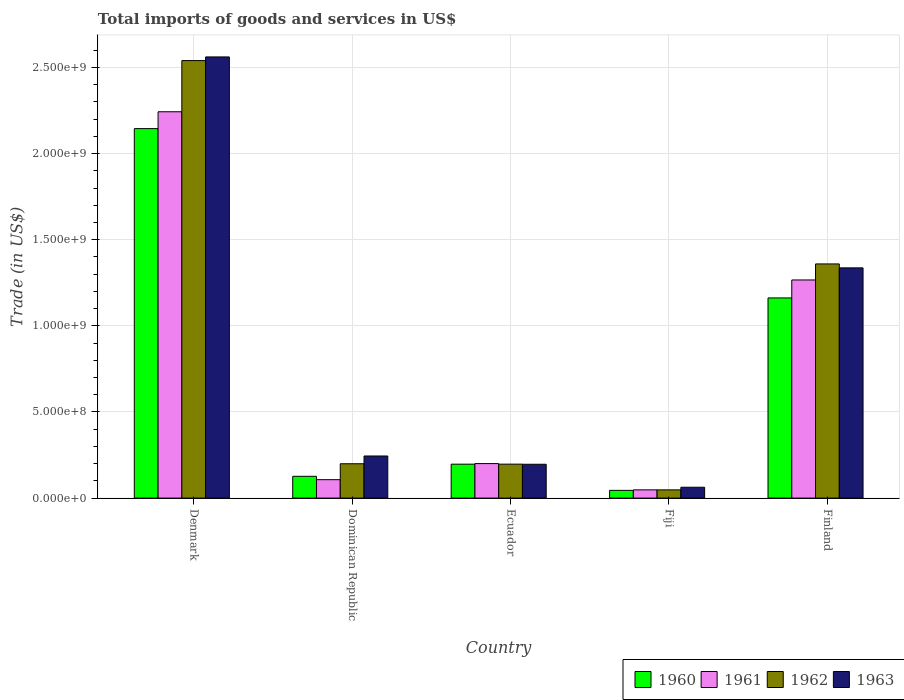How many different coloured bars are there?
Offer a very short reply. 4. Are the number of bars on each tick of the X-axis equal?
Offer a terse response. Yes. How many bars are there on the 4th tick from the left?
Your answer should be compact. 4. How many bars are there on the 3rd tick from the right?
Your response must be concise. 4. In how many cases, is the number of bars for a given country not equal to the number of legend labels?
Your response must be concise. 0. What is the total imports of goods and services in 1961 in Fiji?
Provide a succinct answer. 4.77e+07. Across all countries, what is the maximum total imports of goods and services in 1963?
Make the answer very short. 2.56e+09. Across all countries, what is the minimum total imports of goods and services in 1962?
Keep it short and to the point. 4.77e+07. In which country was the total imports of goods and services in 1962 maximum?
Your answer should be very brief. Denmark. In which country was the total imports of goods and services in 1960 minimum?
Your answer should be compact. Fiji. What is the total total imports of goods and services in 1963 in the graph?
Your answer should be very brief. 4.40e+09. What is the difference between the total imports of goods and services in 1963 in Denmark and that in Finland?
Offer a terse response. 1.22e+09. What is the difference between the total imports of goods and services in 1962 in Ecuador and the total imports of goods and services in 1963 in Fiji?
Offer a terse response. 1.34e+08. What is the average total imports of goods and services in 1961 per country?
Your answer should be very brief. 7.73e+08. What is the difference between the total imports of goods and services of/in 1960 and total imports of goods and services of/in 1961 in Fiji?
Provide a short and direct response. -2.90e+06. What is the ratio of the total imports of goods and services in 1960 in Dominican Republic to that in Finland?
Your response must be concise. 0.11. Is the difference between the total imports of goods and services in 1960 in Denmark and Dominican Republic greater than the difference between the total imports of goods and services in 1961 in Denmark and Dominican Republic?
Give a very brief answer. No. What is the difference between the highest and the second highest total imports of goods and services in 1962?
Offer a very short reply. -1.16e+09. What is the difference between the highest and the lowest total imports of goods and services in 1961?
Provide a succinct answer. 2.19e+09. Is the sum of the total imports of goods and services in 1962 in Fiji and Finland greater than the maximum total imports of goods and services in 1961 across all countries?
Give a very brief answer. No. Is it the case that in every country, the sum of the total imports of goods and services in 1960 and total imports of goods and services in 1962 is greater than the sum of total imports of goods and services in 1961 and total imports of goods and services in 1963?
Give a very brief answer. No. What does the 3rd bar from the right in Fiji represents?
Offer a terse response. 1961. Are the values on the major ticks of Y-axis written in scientific E-notation?
Offer a very short reply. Yes. Does the graph contain any zero values?
Provide a short and direct response. No. How many legend labels are there?
Ensure brevity in your answer.  4. What is the title of the graph?
Provide a short and direct response. Total imports of goods and services in US$. Does "1970" appear as one of the legend labels in the graph?
Your answer should be compact. No. What is the label or title of the Y-axis?
Give a very brief answer. Trade (in US$). What is the Trade (in US$) in 1960 in Denmark?
Give a very brief answer. 2.14e+09. What is the Trade (in US$) of 1961 in Denmark?
Your answer should be compact. 2.24e+09. What is the Trade (in US$) in 1962 in Denmark?
Your response must be concise. 2.54e+09. What is the Trade (in US$) in 1963 in Denmark?
Make the answer very short. 2.56e+09. What is the Trade (in US$) in 1960 in Dominican Republic?
Keep it short and to the point. 1.26e+08. What is the Trade (in US$) of 1961 in Dominican Republic?
Make the answer very short. 1.07e+08. What is the Trade (in US$) in 1962 in Dominican Republic?
Offer a very short reply. 1.99e+08. What is the Trade (in US$) of 1963 in Dominican Republic?
Give a very brief answer. 2.44e+08. What is the Trade (in US$) in 1960 in Ecuador?
Offer a terse response. 1.97e+08. What is the Trade (in US$) in 1961 in Ecuador?
Ensure brevity in your answer.  2.00e+08. What is the Trade (in US$) of 1962 in Ecuador?
Ensure brevity in your answer.  1.97e+08. What is the Trade (in US$) in 1963 in Ecuador?
Give a very brief answer. 1.96e+08. What is the Trade (in US$) in 1960 in Fiji?
Make the answer very short. 4.48e+07. What is the Trade (in US$) in 1961 in Fiji?
Give a very brief answer. 4.77e+07. What is the Trade (in US$) of 1962 in Fiji?
Your response must be concise. 4.77e+07. What is the Trade (in US$) of 1963 in Fiji?
Provide a succinct answer. 6.30e+07. What is the Trade (in US$) in 1960 in Finland?
Keep it short and to the point. 1.16e+09. What is the Trade (in US$) of 1961 in Finland?
Keep it short and to the point. 1.27e+09. What is the Trade (in US$) of 1962 in Finland?
Your response must be concise. 1.36e+09. What is the Trade (in US$) of 1963 in Finland?
Make the answer very short. 1.34e+09. Across all countries, what is the maximum Trade (in US$) in 1960?
Provide a succinct answer. 2.14e+09. Across all countries, what is the maximum Trade (in US$) of 1961?
Offer a terse response. 2.24e+09. Across all countries, what is the maximum Trade (in US$) of 1962?
Provide a short and direct response. 2.54e+09. Across all countries, what is the maximum Trade (in US$) in 1963?
Your response must be concise. 2.56e+09. Across all countries, what is the minimum Trade (in US$) of 1960?
Give a very brief answer. 4.48e+07. Across all countries, what is the minimum Trade (in US$) of 1961?
Make the answer very short. 4.77e+07. Across all countries, what is the minimum Trade (in US$) in 1962?
Your answer should be very brief. 4.77e+07. Across all countries, what is the minimum Trade (in US$) in 1963?
Your answer should be compact. 6.30e+07. What is the total Trade (in US$) in 1960 in the graph?
Offer a very short reply. 3.67e+09. What is the total Trade (in US$) in 1961 in the graph?
Make the answer very short. 3.86e+09. What is the total Trade (in US$) of 1962 in the graph?
Provide a short and direct response. 4.34e+09. What is the total Trade (in US$) in 1963 in the graph?
Offer a very short reply. 4.40e+09. What is the difference between the Trade (in US$) of 1960 in Denmark and that in Dominican Republic?
Your answer should be compact. 2.02e+09. What is the difference between the Trade (in US$) in 1961 in Denmark and that in Dominican Republic?
Provide a succinct answer. 2.14e+09. What is the difference between the Trade (in US$) in 1962 in Denmark and that in Dominican Republic?
Keep it short and to the point. 2.34e+09. What is the difference between the Trade (in US$) in 1963 in Denmark and that in Dominican Republic?
Offer a terse response. 2.32e+09. What is the difference between the Trade (in US$) of 1960 in Denmark and that in Ecuador?
Provide a succinct answer. 1.95e+09. What is the difference between the Trade (in US$) in 1961 in Denmark and that in Ecuador?
Offer a very short reply. 2.04e+09. What is the difference between the Trade (in US$) of 1962 in Denmark and that in Ecuador?
Your answer should be very brief. 2.34e+09. What is the difference between the Trade (in US$) of 1963 in Denmark and that in Ecuador?
Your answer should be very brief. 2.36e+09. What is the difference between the Trade (in US$) in 1960 in Denmark and that in Fiji?
Offer a very short reply. 2.10e+09. What is the difference between the Trade (in US$) in 1961 in Denmark and that in Fiji?
Ensure brevity in your answer.  2.19e+09. What is the difference between the Trade (in US$) of 1962 in Denmark and that in Fiji?
Provide a short and direct response. 2.49e+09. What is the difference between the Trade (in US$) in 1963 in Denmark and that in Fiji?
Offer a terse response. 2.50e+09. What is the difference between the Trade (in US$) in 1960 in Denmark and that in Finland?
Provide a succinct answer. 9.83e+08. What is the difference between the Trade (in US$) of 1961 in Denmark and that in Finland?
Give a very brief answer. 9.76e+08. What is the difference between the Trade (in US$) of 1962 in Denmark and that in Finland?
Your response must be concise. 1.18e+09. What is the difference between the Trade (in US$) in 1963 in Denmark and that in Finland?
Give a very brief answer. 1.22e+09. What is the difference between the Trade (in US$) in 1960 in Dominican Republic and that in Ecuador?
Ensure brevity in your answer.  -7.04e+07. What is the difference between the Trade (in US$) of 1961 in Dominican Republic and that in Ecuador?
Keep it short and to the point. -9.34e+07. What is the difference between the Trade (in US$) in 1962 in Dominican Republic and that in Ecuador?
Provide a succinct answer. 2.27e+06. What is the difference between the Trade (in US$) of 1963 in Dominican Republic and that in Ecuador?
Make the answer very short. 4.80e+07. What is the difference between the Trade (in US$) of 1960 in Dominican Republic and that in Fiji?
Offer a very short reply. 8.17e+07. What is the difference between the Trade (in US$) in 1961 in Dominican Republic and that in Fiji?
Provide a succinct answer. 5.92e+07. What is the difference between the Trade (in US$) of 1962 in Dominican Republic and that in Fiji?
Your answer should be compact. 1.52e+08. What is the difference between the Trade (in US$) in 1963 in Dominican Republic and that in Fiji?
Make the answer very short. 1.81e+08. What is the difference between the Trade (in US$) of 1960 in Dominican Republic and that in Finland?
Offer a terse response. -1.04e+09. What is the difference between the Trade (in US$) in 1961 in Dominican Republic and that in Finland?
Provide a short and direct response. -1.16e+09. What is the difference between the Trade (in US$) in 1962 in Dominican Republic and that in Finland?
Ensure brevity in your answer.  -1.16e+09. What is the difference between the Trade (in US$) in 1963 in Dominican Republic and that in Finland?
Offer a terse response. -1.09e+09. What is the difference between the Trade (in US$) in 1960 in Ecuador and that in Fiji?
Provide a short and direct response. 1.52e+08. What is the difference between the Trade (in US$) of 1961 in Ecuador and that in Fiji?
Your answer should be very brief. 1.53e+08. What is the difference between the Trade (in US$) of 1962 in Ecuador and that in Fiji?
Provide a succinct answer. 1.49e+08. What is the difference between the Trade (in US$) of 1963 in Ecuador and that in Fiji?
Provide a short and direct response. 1.33e+08. What is the difference between the Trade (in US$) in 1960 in Ecuador and that in Finland?
Your answer should be compact. -9.65e+08. What is the difference between the Trade (in US$) in 1961 in Ecuador and that in Finland?
Your answer should be compact. -1.07e+09. What is the difference between the Trade (in US$) in 1962 in Ecuador and that in Finland?
Your response must be concise. -1.16e+09. What is the difference between the Trade (in US$) of 1963 in Ecuador and that in Finland?
Make the answer very short. -1.14e+09. What is the difference between the Trade (in US$) in 1960 in Fiji and that in Finland?
Ensure brevity in your answer.  -1.12e+09. What is the difference between the Trade (in US$) of 1961 in Fiji and that in Finland?
Your answer should be very brief. -1.22e+09. What is the difference between the Trade (in US$) of 1962 in Fiji and that in Finland?
Make the answer very short. -1.31e+09. What is the difference between the Trade (in US$) of 1963 in Fiji and that in Finland?
Provide a short and direct response. -1.27e+09. What is the difference between the Trade (in US$) in 1960 in Denmark and the Trade (in US$) in 1961 in Dominican Republic?
Your response must be concise. 2.04e+09. What is the difference between the Trade (in US$) in 1960 in Denmark and the Trade (in US$) in 1962 in Dominican Republic?
Your answer should be very brief. 1.95e+09. What is the difference between the Trade (in US$) of 1960 in Denmark and the Trade (in US$) of 1963 in Dominican Republic?
Your answer should be compact. 1.90e+09. What is the difference between the Trade (in US$) in 1961 in Denmark and the Trade (in US$) in 1962 in Dominican Republic?
Your response must be concise. 2.04e+09. What is the difference between the Trade (in US$) in 1961 in Denmark and the Trade (in US$) in 1963 in Dominican Republic?
Offer a very short reply. 2.00e+09. What is the difference between the Trade (in US$) in 1962 in Denmark and the Trade (in US$) in 1963 in Dominican Republic?
Your answer should be compact. 2.30e+09. What is the difference between the Trade (in US$) in 1960 in Denmark and the Trade (in US$) in 1961 in Ecuador?
Give a very brief answer. 1.94e+09. What is the difference between the Trade (in US$) in 1960 in Denmark and the Trade (in US$) in 1962 in Ecuador?
Offer a very short reply. 1.95e+09. What is the difference between the Trade (in US$) in 1960 in Denmark and the Trade (in US$) in 1963 in Ecuador?
Ensure brevity in your answer.  1.95e+09. What is the difference between the Trade (in US$) in 1961 in Denmark and the Trade (in US$) in 1962 in Ecuador?
Give a very brief answer. 2.05e+09. What is the difference between the Trade (in US$) of 1961 in Denmark and the Trade (in US$) of 1963 in Ecuador?
Your answer should be very brief. 2.05e+09. What is the difference between the Trade (in US$) of 1962 in Denmark and the Trade (in US$) of 1963 in Ecuador?
Offer a very short reply. 2.34e+09. What is the difference between the Trade (in US$) of 1960 in Denmark and the Trade (in US$) of 1961 in Fiji?
Provide a short and direct response. 2.10e+09. What is the difference between the Trade (in US$) in 1960 in Denmark and the Trade (in US$) in 1962 in Fiji?
Your response must be concise. 2.10e+09. What is the difference between the Trade (in US$) in 1960 in Denmark and the Trade (in US$) in 1963 in Fiji?
Keep it short and to the point. 2.08e+09. What is the difference between the Trade (in US$) in 1961 in Denmark and the Trade (in US$) in 1962 in Fiji?
Offer a very short reply. 2.19e+09. What is the difference between the Trade (in US$) in 1961 in Denmark and the Trade (in US$) in 1963 in Fiji?
Your response must be concise. 2.18e+09. What is the difference between the Trade (in US$) in 1962 in Denmark and the Trade (in US$) in 1963 in Fiji?
Provide a short and direct response. 2.48e+09. What is the difference between the Trade (in US$) of 1960 in Denmark and the Trade (in US$) of 1961 in Finland?
Your response must be concise. 8.79e+08. What is the difference between the Trade (in US$) of 1960 in Denmark and the Trade (in US$) of 1962 in Finland?
Offer a very short reply. 7.85e+08. What is the difference between the Trade (in US$) in 1960 in Denmark and the Trade (in US$) in 1963 in Finland?
Provide a succinct answer. 8.08e+08. What is the difference between the Trade (in US$) in 1961 in Denmark and the Trade (in US$) in 1962 in Finland?
Your answer should be very brief. 8.83e+08. What is the difference between the Trade (in US$) of 1961 in Denmark and the Trade (in US$) of 1963 in Finland?
Provide a short and direct response. 9.06e+08. What is the difference between the Trade (in US$) in 1962 in Denmark and the Trade (in US$) in 1963 in Finland?
Offer a very short reply. 1.20e+09. What is the difference between the Trade (in US$) of 1960 in Dominican Republic and the Trade (in US$) of 1961 in Ecuador?
Your answer should be very brief. -7.38e+07. What is the difference between the Trade (in US$) in 1960 in Dominican Republic and the Trade (in US$) in 1962 in Ecuador?
Give a very brief answer. -7.05e+07. What is the difference between the Trade (in US$) in 1960 in Dominican Republic and the Trade (in US$) in 1963 in Ecuador?
Make the answer very short. -6.99e+07. What is the difference between the Trade (in US$) of 1961 in Dominican Republic and the Trade (in US$) of 1962 in Ecuador?
Keep it short and to the point. -9.01e+07. What is the difference between the Trade (in US$) of 1961 in Dominican Republic and the Trade (in US$) of 1963 in Ecuador?
Keep it short and to the point. -8.95e+07. What is the difference between the Trade (in US$) in 1962 in Dominican Republic and the Trade (in US$) in 1963 in Ecuador?
Keep it short and to the point. 2.94e+06. What is the difference between the Trade (in US$) of 1960 in Dominican Republic and the Trade (in US$) of 1961 in Fiji?
Your answer should be very brief. 7.88e+07. What is the difference between the Trade (in US$) of 1960 in Dominican Republic and the Trade (in US$) of 1962 in Fiji?
Give a very brief answer. 7.88e+07. What is the difference between the Trade (in US$) in 1960 in Dominican Republic and the Trade (in US$) in 1963 in Fiji?
Make the answer very short. 6.35e+07. What is the difference between the Trade (in US$) of 1961 in Dominican Republic and the Trade (in US$) of 1962 in Fiji?
Ensure brevity in your answer.  5.92e+07. What is the difference between the Trade (in US$) of 1961 in Dominican Republic and the Trade (in US$) of 1963 in Fiji?
Your response must be concise. 4.39e+07. What is the difference between the Trade (in US$) of 1962 in Dominican Republic and the Trade (in US$) of 1963 in Fiji?
Provide a succinct answer. 1.36e+08. What is the difference between the Trade (in US$) of 1960 in Dominican Republic and the Trade (in US$) of 1961 in Finland?
Your response must be concise. -1.14e+09. What is the difference between the Trade (in US$) in 1960 in Dominican Republic and the Trade (in US$) in 1962 in Finland?
Provide a short and direct response. -1.23e+09. What is the difference between the Trade (in US$) in 1960 in Dominican Republic and the Trade (in US$) in 1963 in Finland?
Provide a short and direct response. -1.21e+09. What is the difference between the Trade (in US$) in 1961 in Dominican Republic and the Trade (in US$) in 1962 in Finland?
Offer a very short reply. -1.25e+09. What is the difference between the Trade (in US$) of 1961 in Dominican Republic and the Trade (in US$) of 1963 in Finland?
Keep it short and to the point. -1.23e+09. What is the difference between the Trade (in US$) of 1962 in Dominican Republic and the Trade (in US$) of 1963 in Finland?
Keep it short and to the point. -1.14e+09. What is the difference between the Trade (in US$) of 1960 in Ecuador and the Trade (in US$) of 1961 in Fiji?
Offer a terse response. 1.49e+08. What is the difference between the Trade (in US$) in 1960 in Ecuador and the Trade (in US$) in 1962 in Fiji?
Give a very brief answer. 1.49e+08. What is the difference between the Trade (in US$) of 1960 in Ecuador and the Trade (in US$) of 1963 in Fiji?
Your answer should be compact. 1.34e+08. What is the difference between the Trade (in US$) of 1961 in Ecuador and the Trade (in US$) of 1962 in Fiji?
Offer a very short reply. 1.53e+08. What is the difference between the Trade (in US$) of 1961 in Ecuador and the Trade (in US$) of 1963 in Fiji?
Your response must be concise. 1.37e+08. What is the difference between the Trade (in US$) in 1962 in Ecuador and the Trade (in US$) in 1963 in Fiji?
Ensure brevity in your answer.  1.34e+08. What is the difference between the Trade (in US$) of 1960 in Ecuador and the Trade (in US$) of 1961 in Finland?
Your answer should be compact. -1.07e+09. What is the difference between the Trade (in US$) of 1960 in Ecuador and the Trade (in US$) of 1962 in Finland?
Ensure brevity in your answer.  -1.16e+09. What is the difference between the Trade (in US$) of 1960 in Ecuador and the Trade (in US$) of 1963 in Finland?
Offer a terse response. -1.14e+09. What is the difference between the Trade (in US$) in 1961 in Ecuador and the Trade (in US$) in 1962 in Finland?
Offer a very short reply. -1.16e+09. What is the difference between the Trade (in US$) in 1961 in Ecuador and the Trade (in US$) in 1963 in Finland?
Make the answer very short. -1.14e+09. What is the difference between the Trade (in US$) of 1962 in Ecuador and the Trade (in US$) of 1963 in Finland?
Offer a terse response. -1.14e+09. What is the difference between the Trade (in US$) of 1960 in Fiji and the Trade (in US$) of 1961 in Finland?
Keep it short and to the point. -1.22e+09. What is the difference between the Trade (in US$) of 1960 in Fiji and the Trade (in US$) of 1962 in Finland?
Ensure brevity in your answer.  -1.31e+09. What is the difference between the Trade (in US$) in 1960 in Fiji and the Trade (in US$) in 1963 in Finland?
Give a very brief answer. -1.29e+09. What is the difference between the Trade (in US$) of 1961 in Fiji and the Trade (in US$) of 1962 in Finland?
Give a very brief answer. -1.31e+09. What is the difference between the Trade (in US$) of 1961 in Fiji and the Trade (in US$) of 1963 in Finland?
Your response must be concise. -1.29e+09. What is the difference between the Trade (in US$) in 1962 in Fiji and the Trade (in US$) in 1963 in Finland?
Keep it short and to the point. -1.29e+09. What is the average Trade (in US$) in 1960 per country?
Ensure brevity in your answer.  7.35e+08. What is the average Trade (in US$) in 1961 per country?
Your answer should be very brief. 7.73e+08. What is the average Trade (in US$) in 1962 per country?
Ensure brevity in your answer.  8.69e+08. What is the average Trade (in US$) of 1963 per country?
Keep it short and to the point. 8.80e+08. What is the difference between the Trade (in US$) of 1960 and Trade (in US$) of 1961 in Denmark?
Your answer should be very brief. -9.78e+07. What is the difference between the Trade (in US$) of 1960 and Trade (in US$) of 1962 in Denmark?
Your response must be concise. -3.95e+08. What is the difference between the Trade (in US$) of 1960 and Trade (in US$) of 1963 in Denmark?
Your answer should be compact. -4.16e+08. What is the difference between the Trade (in US$) of 1961 and Trade (in US$) of 1962 in Denmark?
Provide a succinct answer. -2.97e+08. What is the difference between the Trade (in US$) in 1961 and Trade (in US$) in 1963 in Denmark?
Your answer should be compact. -3.18e+08. What is the difference between the Trade (in US$) in 1962 and Trade (in US$) in 1963 in Denmark?
Keep it short and to the point. -2.12e+07. What is the difference between the Trade (in US$) of 1960 and Trade (in US$) of 1961 in Dominican Republic?
Provide a short and direct response. 1.96e+07. What is the difference between the Trade (in US$) in 1960 and Trade (in US$) in 1962 in Dominican Republic?
Give a very brief answer. -7.28e+07. What is the difference between the Trade (in US$) of 1960 and Trade (in US$) of 1963 in Dominican Republic?
Make the answer very short. -1.18e+08. What is the difference between the Trade (in US$) in 1961 and Trade (in US$) in 1962 in Dominican Republic?
Keep it short and to the point. -9.24e+07. What is the difference between the Trade (in US$) in 1961 and Trade (in US$) in 1963 in Dominican Republic?
Your answer should be very brief. -1.38e+08. What is the difference between the Trade (in US$) of 1962 and Trade (in US$) of 1963 in Dominican Republic?
Offer a very short reply. -4.51e+07. What is the difference between the Trade (in US$) of 1960 and Trade (in US$) of 1961 in Ecuador?
Make the answer very short. -3.37e+06. What is the difference between the Trade (in US$) of 1960 and Trade (in US$) of 1962 in Ecuador?
Your answer should be compact. -1.34e+05. What is the difference between the Trade (in US$) of 1960 and Trade (in US$) of 1963 in Ecuador?
Make the answer very short. 5.38e+05. What is the difference between the Trade (in US$) in 1961 and Trade (in US$) in 1962 in Ecuador?
Provide a short and direct response. 3.24e+06. What is the difference between the Trade (in US$) in 1961 and Trade (in US$) in 1963 in Ecuador?
Provide a short and direct response. 3.91e+06. What is the difference between the Trade (in US$) in 1962 and Trade (in US$) in 1963 in Ecuador?
Your answer should be very brief. 6.72e+05. What is the difference between the Trade (in US$) in 1960 and Trade (in US$) in 1961 in Fiji?
Provide a succinct answer. -2.90e+06. What is the difference between the Trade (in US$) of 1960 and Trade (in US$) of 1962 in Fiji?
Keep it short and to the point. -2.90e+06. What is the difference between the Trade (in US$) in 1960 and Trade (in US$) in 1963 in Fiji?
Offer a terse response. -1.81e+07. What is the difference between the Trade (in US$) in 1961 and Trade (in US$) in 1962 in Fiji?
Provide a short and direct response. 0. What is the difference between the Trade (in US$) of 1961 and Trade (in US$) of 1963 in Fiji?
Ensure brevity in your answer.  -1.52e+07. What is the difference between the Trade (in US$) of 1962 and Trade (in US$) of 1963 in Fiji?
Provide a short and direct response. -1.52e+07. What is the difference between the Trade (in US$) of 1960 and Trade (in US$) of 1961 in Finland?
Provide a succinct answer. -1.04e+08. What is the difference between the Trade (in US$) of 1960 and Trade (in US$) of 1962 in Finland?
Ensure brevity in your answer.  -1.97e+08. What is the difference between the Trade (in US$) of 1960 and Trade (in US$) of 1963 in Finland?
Your answer should be very brief. -1.75e+08. What is the difference between the Trade (in US$) in 1961 and Trade (in US$) in 1962 in Finland?
Ensure brevity in your answer.  -9.31e+07. What is the difference between the Trade (in US$) in 1961 and Trade (in US$) in 1963 in Finland?
Ensure brevity in your answer.  -7.02e+07. What is the difference between the Trade (in US$) of 1962 and Trade (in US$) of 1963 in Finland?
Offer a very short reply. 2.29e+07. What is the ratio of the Trade (in US$) of 1960 in Denmark to that in Dominican Republic?
Your answer should be very brief. 16.95. What is the ratio of the Trade (in US$) of 1961 in Denmark to that in Dominican Republic?
Offer a terse response. 20.98. What is the ratio of the Trade (in US$) of 1962 in Denmark to that in Dominican Republic?
Your answer should be compact. 12.74. What is the ratio of the Trade (in US$) of 1963 in Denmark to that in Dominican Republic?
Provide a short and direct response. 10.48. What is the ratio of the Trade (in US$) of 1960 in Denmark to that in Ecuador?
Keep it short and to the point. 10.89. What is the ratio of the Trade (in US$) in 1961 in Denmark to that in Ecuador?
Offer a terse response. 11.2. What is the ratio of the Trade (in US$) of 1962 in Denmark to that in Ecuador?
Provide a short and direct response. 12.89. What is the ratio of the Trade (in US$) of 1963 in Denmark to that in Ecuador?
Your answer should be compact. 13.04. What is the ratio of the Trade (in US$) of 1960 in Denmark to that in Fiji?
Your answer should be very brief. 47.84. What is the ratio of the Trade (in US$) of 1961 in Denmark to that in Fiji?
Your answer should be compact. 46.98. What is the ratio of the Trade (in US$) in 1962 in Denmark to that in Fiji?
Offer a very short reply. 53.21. What is the ratio of the Trade (in US$) of 1963 in Denmark to that in Fiji?
Your response must be concise. 40.67. What is the ratio of the Trade (in US$) in 1960 in Denmark to that in Finland?
Your response must be concise. 1.85. What is the ratio of the Trade (in US$) of 1961 in Denmark to that in Finland?
Give a very brief answer. 1.77. What is the ratio of the Trade (in US$) in 1962 in Denmark to that in Finland?
Provide a succinct answer. 1.87. What is the ratio of the Trade (in US$) in 1963 in Denmark to that in Finland?
Keep it short and to the point. 1.92. What is the ratio of the Trade (in US$) of 1960 in Dominican Republic to that in Ecuador?
Keep it short and to the point. 0.64. What is the ratio of the Trade (in US$) of 1961 in Dominican Republic to that in Ecuador?
Offer a very short reply. 0.53. What is the ratio of the Trade (in US$) of 1962 in Dominican Republic to that in Ecuador?
Provide a short and direct response. 1.01. What is the ratio of the Trade (in US$) of 1963 in Dominican Republic to that in Ecuador?
Offer a very short reply. 1.24. What is the ratio of the Trade (in US$) in 1960 in Dominican Republic to that in Fiji?
Make the answer very short. 2.82. What is the ratio of the Trade (in US$) in 1961 in Dominican Republic to that in Fiji?
Your response must be concise. 2.24. What is the ratio of the Trade (in US$) of 1962 in Dominican Republic to that in Fiji?
Ensure brevity in your answer.  4.18. What is the ratio of the Trade (in US$) in 1963 in Dominican Republic to that in Fiji?
Make the answer very short. 3.88. What is the ratio of the Trade (in US$) of 1960 in Dominican Republic to that in Finland?
Give a very brief answer. 0.11. What is the ratio of the Trade (in US$) of 1961 in Dominican Republic to that in Finland?
Make the answer very short. 0.08. What is the ratio of the Trade (in US$) of 1962 in Dominican Republic to that in Finland?
Your answer should be compact. 0.15. What is the ratio of the Trade (in US$) in 1963 in Dominican Republic to that in Finland?
Your answer should be very brief. 0.18. What is the ratio of the Trade (in US$) of 1960 in Ecuador to that in Fiji?
Make the answer very short. 4.39. What is the ratio of the Trade (in US$) in 1961 in Ecuador to that in Fiji?
Offer a very short reply. 4.2. What is the ratio of the Trade (in US$) of 1962 in Ecuador to that in Fiji?
Keep it short and to the point. 4.13. What is the ratio of the Trade (in US$) of 1963 in Ecuador to that in Fiji?
Your answer should be compact. 3.12. What is the ratio of the Trade (in US$) in 1960 in Ecuador to that in Finland?
Make the answer very short. 0.17. What is the ratio of the Trade (in US$) in 1961 in Ecuador to that in Finland?
Offer a very short reply. 0.16. What is the ratio of the Trade (in US$) in 1962 in Ecuador to that in Finland?
Provide a succinct answer. 0.14. What is the ratio of the Trade (in US$) in 1963 in Ecuador to that in Finland?
Offer a very short reply. 0.15. What is the ratio of the Trade (in US$) in 1960 in Fiji to that in Finland?
Make the answer very short. 0.04. What is the ratio of the Trade (in US$) in 1961 in Fiji to that in Finland?
Your response must be concise. 0.04. What is the ratio of the Trade (in US$) of 1962 in Fiji to that in Finland?
Offer a very short reply. 0.04. What is the ratio of the Trade (in US$) in 1963 in Fiji to that in Finland?
Keep it short and to the point. 0.05. What is the difference between the highest and the second highest Trade (in US$) in 1960?
Your answer should be very brief. 9.83e+08. What is the difference between the highest and the second highest Trade (in US$) of 1961?
Offer a terse response. 9.76e+08. What is the difference between the highest and the second highest Trade (in US$) of 1962?
Your response must be concise. 1.18e+09. What is the difference between the highest and the second highest Trade (in US$) of 1963?
Provide a succinct answer. 1.22e+09. What is the difference between the highest and the lowest Trade (in US$) of 1960?
Your answer should be very brief. 2.10e+09. What is the difference between the highest and the lowest Trade (in US$) in 1961?
Your answer should be very brief. 2.19e+09. What is the difference between the highest and the lowest Trade (in US$) of 1962?
Provide a short and direct response. 2.49e+09. What is the difference between the highest and the lowest Trade (in US$) of 1963?
Your answer should be compact. 2.50e+09. 